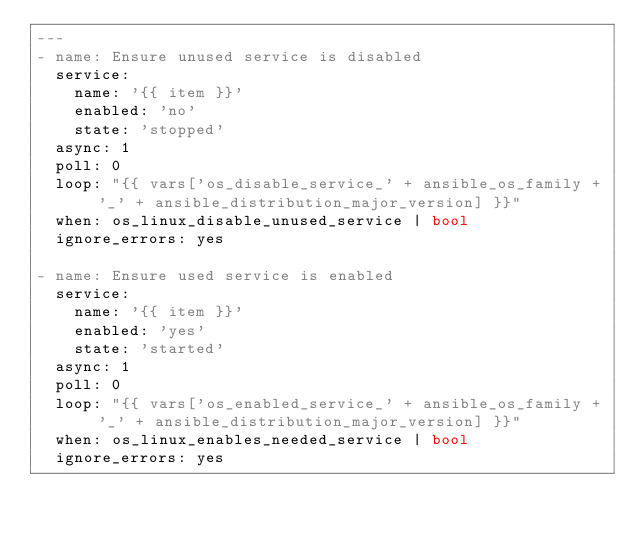Convert code to text. <code><loc_0><loc_0><loc_500><loc_500><_YAML_>---
- name: Ensure unused service is disabled
  service:
    name: '{{ item }}'
    enabled: 'no'
    state: 'stopped'
  async: 1
  poll: 0
  loop: "{{ vars['os_disable_service_' + ansible_os_family + '_' + ansible_distribution_major_version] }}"
  when: os_linux_disable_unused_service | bool
  ignore_errors: yes

- name: Ensure used service is enabled
  service:
    name: '{{ item }}'
    enabled: 'yes'
    state: 'started'
  async: 1
  poll: 0
  loop: "{{ vars['os_enabled_service_' + ansible_os_family + '_' + ansible_distribution_major_version] }}"
  when: os_linux_enables_needed_service | bool
  ignore_errors: yes
</code> 